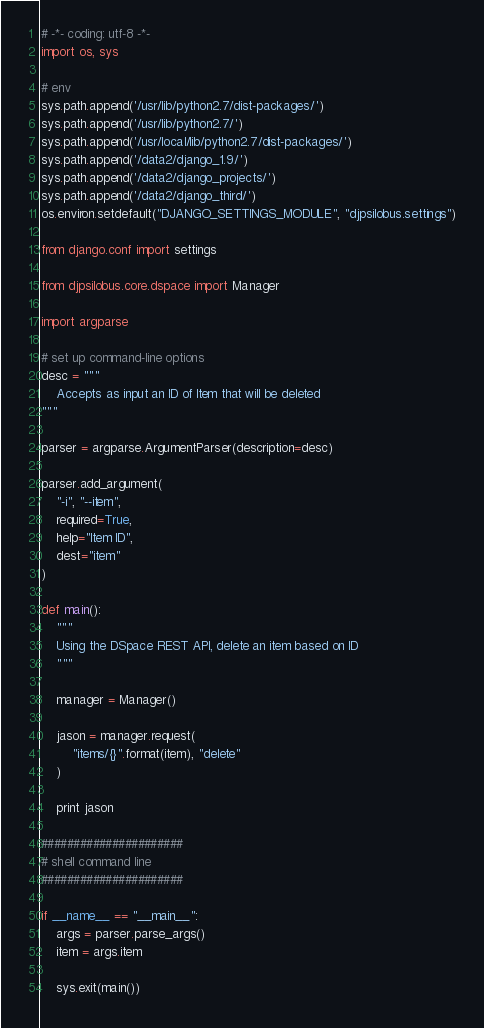Convert code to text. <code><loc_0><loc_0><loc_500><loc_500><_Python_># -*- coding: utf-8 -*-
import os, sys

# env
sys.path.append('/usr/lib/python2.7/dist-packages/')
sys.path.append('/usr/lib/python2.7/')
sys.path.append('/usr/local/lib/python2.7/dist-packages/')
sys.path.append('/data2/django_1.9/')
sys.path.append('/data2/django_projects/')
sys.path.append('/data2/django_third/')
os.environ.setdefault("DJANGO_SETTINGS_MODULE", "djpsilobus.settings")

from django.conf import settings

from djpsilobus.core.dspace import Manager

import argparse

# set up command-line options
desc = """
    Accepts as input an ID of Item that will be deleted
"""

parser = argparse.ArgumentParser(description=desc)

parser.add_argument(
    "-i", "--item",
    required=True,
    help="Item ID",
    dest="item"
)

def main():
    """
    Using the DSpace REST API, delete an item based on ID
    """

    manager = Manager()

    jason = manager.request(
        "items/{}".format(item), "delete"
    )

    print jason

######################
# shell command line
######################

if __name__ == "__main__":
    args = parser.parse_args()
    item = args.item

    sys.exit(main())
</code> 